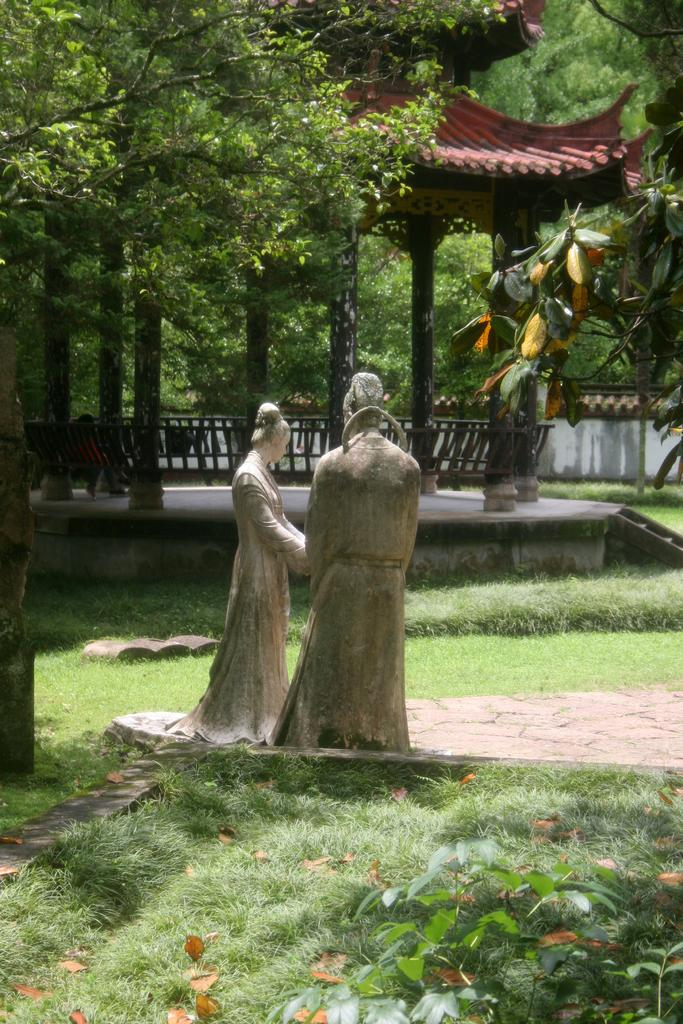What is the main subject in the center of the image? There are statues in the center of the image. What can be seen in the background of the image? There is a roof for shelter and trees in the background of the image. What type of vegetation is present at the bottom of the image? There is grass and plants at the bottom of the image. What type of jewel can be seen in the image? There is no jewel present in the image. What type of journey or voyage is depicted in the image? There is no journey or voyage depicted in the image; it features statues, a roof, trees, grass, and plants. 